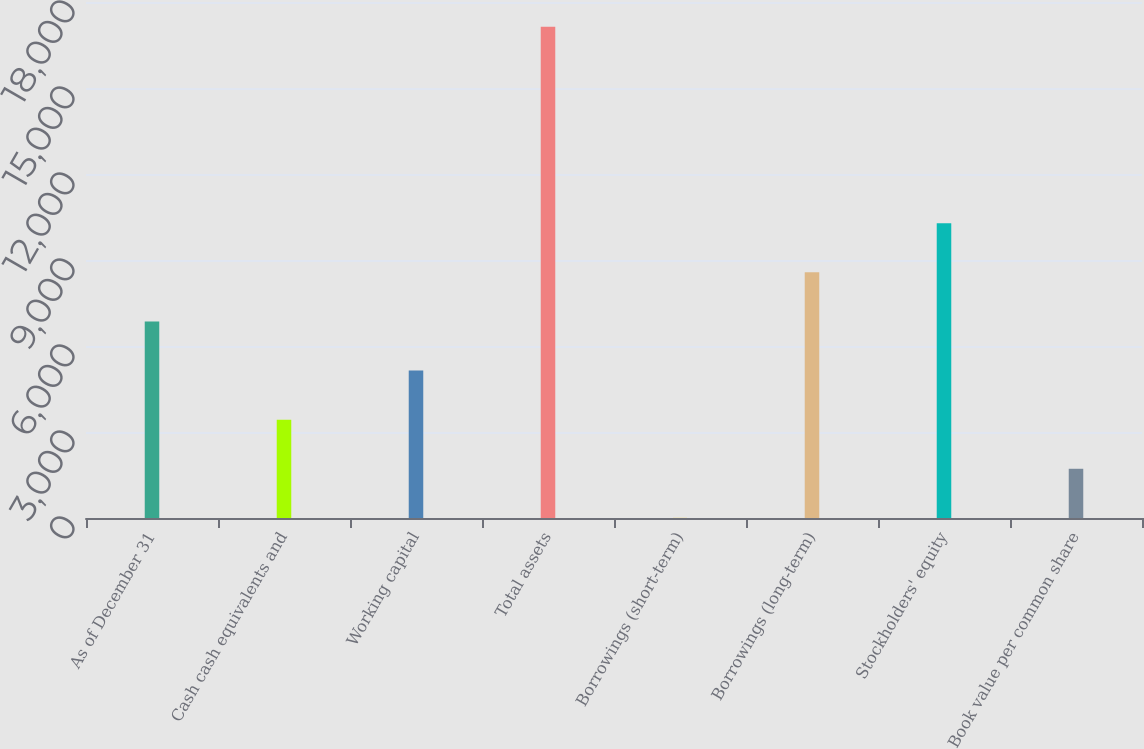Convert chart to OTSL. <chart><loc_0><loc_0><loc_500><loc_500><bar_chart><fcel>As of December 31<fcel>Cash cash equivalents and<fcel>Working capital<fcel>Total assets<fcel>Borrowings (short-term)<fcel>Borrowings (long-term)<fcel>Stockholders' equity<fcel>Book value per common share<nl><fcel>6856.8<fcel>3430.4<fcel>5143.6<fcel>17136<fcel>4<fcel>8570<fcel>10283.2<fcel>1717.2<nl></chart> 